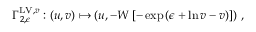<formula> <loc_0><loc_0><loc_500><loc_500>\Gamma _ { 2 , \epsilon } ^ { L V , v } \colon ( u , v ) \mapsto \left ( u , - W \left [ - \exp \left ( \epsilon + \ln v - v \right ) \right ] \right ) \, ,</formula> 